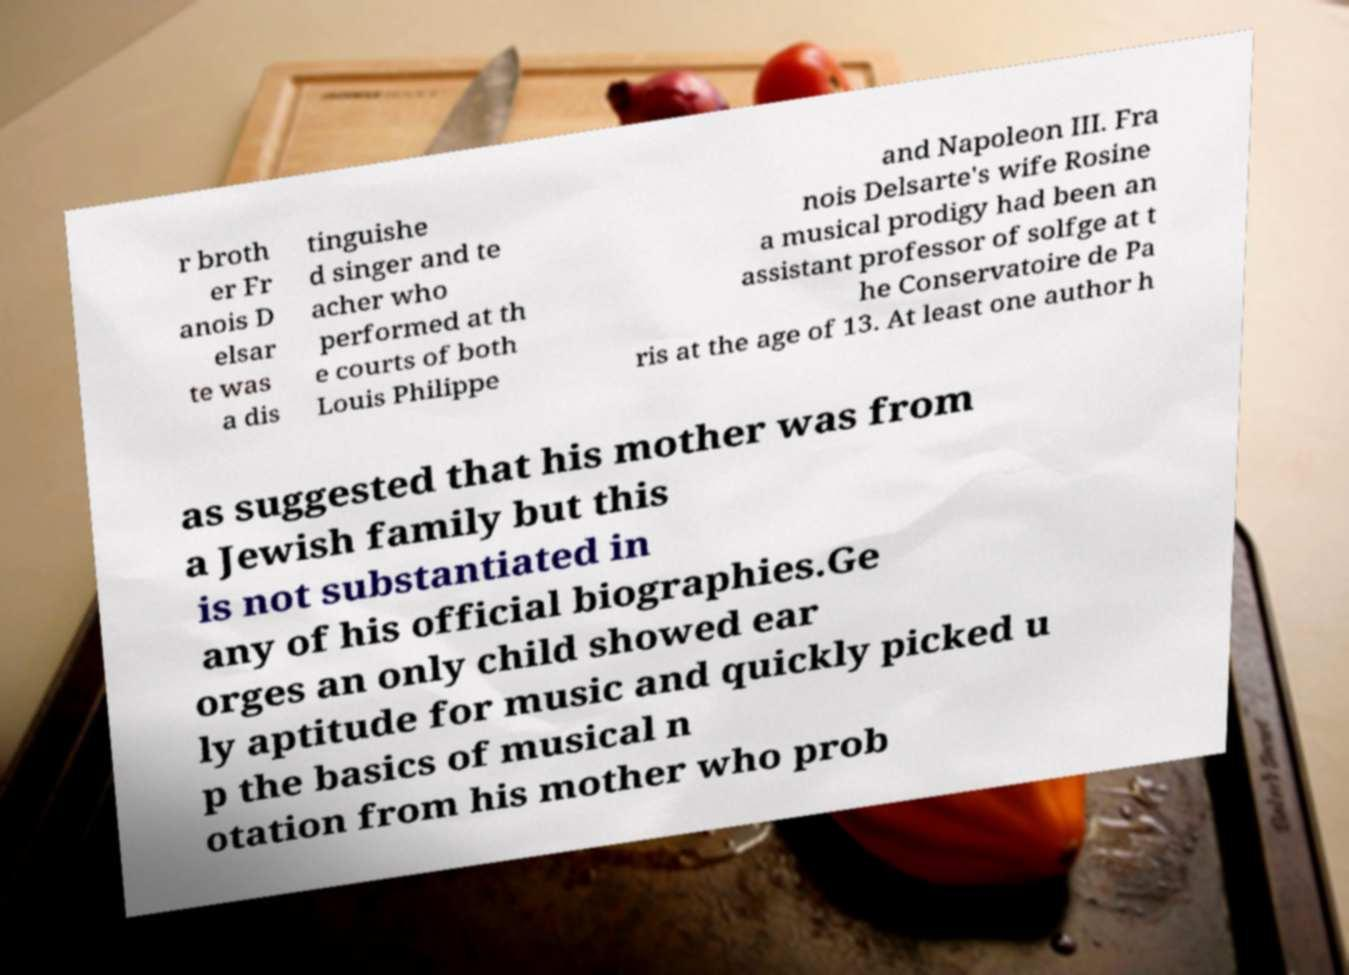What messages or text are displayed in this image? I need them in a readable, typed format. r broth er Fr anois D elsar te was a dis tinguishe d singer and te acher who performed at th e courts of both Louis Philippe and Napoleon III. Fra nois Delsarte's wife Rosine a musical prodigy had been an assistant professor of solfge at t he Conservatoire de Pa ris at the age of 13. At least one author h as suggested that his mother was from a Jewish family but this is not substantiated in any of his official biographies.Ge orges an only child showed ear ly aptitude for music and quickly picked u p the basics of musical n otation from his mother who prob 